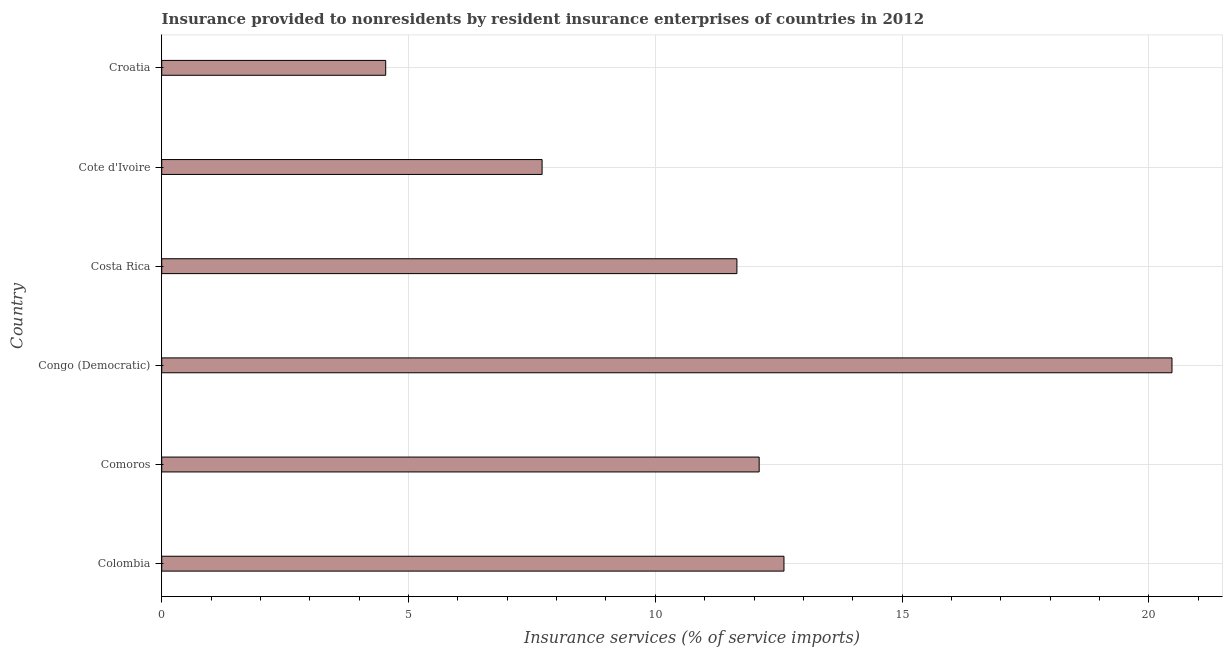Does the graph contain any zero values?
Provide a succinct answer. No. What is the title of the graph?
Offer a very short reply. Insurance provided to nonresidents by resident insurance enterprises of countries in 2012. What is the label or title of the X-axis?
Provide a succinct answer. Insurance services (% of service imports). What is the insurance and financial services in Croatia?
Give a very brief answer. 4.54. Across all countries, what is the maximum insurance and financial services?
Provide a succinct answer. 20.47. Across all countries, what is the minimum insurance and financial services?
Offer a very short reply. 4.54. In which country was the insurance and financial services maximum?
Your answer should be very brief. Congo (Democratic). In which country was the insurance and financial services minimum?
Provide a succinct answer. Croatia. What is the sum of the insurance and financial services?
Provide a short and direct response. 69.07. What is the average insurance and financial services per country?
Offer a very short reply. 11.51. What is the median insurance and financial services?
Offer a terse response. 11.88. In how many countries, is the insurance and financial services greater than 10 %?
Your answer should be compact. 4. What is the ratio of the insurance and financial services in Comoros to that in Costa Rica?
Give a very brief answer. 1.04. Is the insurance and financial services in Congo (Democratic) less than that in Croatia?
Ensure brevity in your answer.  No. What is the difference between the highest and the second highest insurance and financial services?
Offer a terse response. 7.86. What is the difference between the highest and the lowest insurance and financial services?
Offer a very short reply. 15.93. In how many countries, is the insurance and financial services greater than the average insurance and financial services taken over all countries?
Provide a succinct answer. 4. How many bars are there?
Keep it short and to the point. 6. Are all the bars in the graph horizontal?
Your answer should be compact. Yes. Are the values on the major ticks of X-axis written in scientific E-notation?
Make the answer very short. No. What is the Insurance services (% of service imports) of Colombia?
Provide a succinct answer. 12.61. What is the Insurance services (% of service imports) in Comoros?
Make the answer very short. 12.1. What is the Insurance services (% of service imports) in Congo (Democratic)?
Your answer should be compact. 20.47. What is the Insurance services (% of service imports) of Costa Rica?
Your answer should be very brief. 11.65. What is the Insurance services (% of service imports) in Cote d'Ivoire?
Provide a succinct answer. 7.71. What is the Insurance services (% of service imports) in Croatia?
Offer a terse response. 4.54. What is the difference between the Insurance services (% of service imports) in Colombia and Comoros?
Your answer should be compact. 0.5. What is the difference between the Insurance services (% of service imports) in Colombia and Congo (Democratic)?
Offer a very short reply. -7.86. What is the difference between the Insurance services (% of service imports) in Colombia and Costa Rica?
Your answer should be very brief. 0.95. What is the difference between the Insurance services (% of service imports) in Colombia and Cote d'Ivoire?
Provide a short and direct response. 4.9. What is the difference between the Insurance services (% of service imports) in Colombia and Croatia?
Your response must be concise. 8.07. What is the difference between the Insurance services (% of service imports) in Comoros and Congo (Democratic)?
Provide a succinct answer. -8.36. What is the difference between the Insurance services (% of service imports) in Comoros and Costa Rica?
Provide a succinct answer. 0.45. What is the difference between the Insurance services (% of service imports) in Comoros and Cote d'Ivoire?
Offer a terse response. 4.4. What is the difference between the Insurance services (% of service imports) in Comoros and Croatia?
Your answer should be compact. 7.57. What is the difference between the Insurance services (% of service imports) in Congo (Democratic) and Costa Rica?
Your response must be concise. 8.81. What is the difference between the Insurance services (% of service imports) in Congo (Democratic) and Cote d'Ivoire?
Offer a very short reply. 12.76. What is the difference between the Insurance services (% of service imports) in Congo (Democratic) and Croatia?
Give a very brief answer. 15.93. What is the difference between the Insurance services (% of service imports) in Costa Rica and Cote d'Ivoire?
Provide a succinct answer. 3.95. What is the difference between the Insurance services (% of service imports) in Costa Rica and Croatia?
Ensure brevity in your answer.  7.11. What is the difference between the Insurance services (% of service imports) in Cote d'Ivoire and Croatia?
Provide a succinct answer. 3.17. What is the ratio of the Insurance services (% of service imports) in Colombia to that in Comoros?
Give a very brief answer. 1.04. What is the ratio of the Insurance services (% of service imports) in Colombia to that in Congo (Democratic)?
Your answer should be very brief. 0.62. What is the ratio of the Insurance services (% of service imports) in Colombia to that in Costa Rica?
Make the answer very short. 1.08. What is the ratio of the Insurance services (% of service imports) in Colombia to that in Cote d'Ivoire?
Your answer should be very brief. 1.64. What is the ratio of the Insurance services (% of service imports) in Colombia to that in Croatia?
Provide a short and direct response. 2.78. What is the ratio of the Insurance services (% of service imports) in Comoros to that in Congo (Democratic)?
Your answer should be compact. 0.59. What is the ratio of the Insurance services (% of service imports) in Comoros to that in Costa Rica?
Offer a very short reply. 1.04. What is the ratio of the Insurance services (% of service imports) in Comoros to that in Cote d'Ivoire?
Offer a very short reply. 1.57. What is the ratio of the Insurance services (% of service imports) in Comoros to that in Croatia?
Make the answer very short. 2.67. What is the ratio of the Insurance services (% of service imports) in Congo (Democratic) to that in Costa Rica?
Your response must be concise. 1.76. What is the ratio of the Insurance services (% of service imports) in Congo (Democratic) to that in Cote d'Ivoire?
Offer a terse response. 2.66. What is the ratio of the Insurance services (% of service imports) in Congo (Democratic) to that in Croatia?
Offer a very short reply. 4.51. What is the ratio of the Insurance services (% of service imports) in Costa Rica to that in Cote d'Ivoire?
Give a very brief answer. 1.51. What is the ratio of the Insurance services (% of service imports) in Costa Rica to that in Croatia?
Keep it short and to the point. 2.57. What is the ratio of the Insurance services (% of service imports) in Cote d'Ivoire to that in Croatia?
Keep it short and to the point. 1.7. 